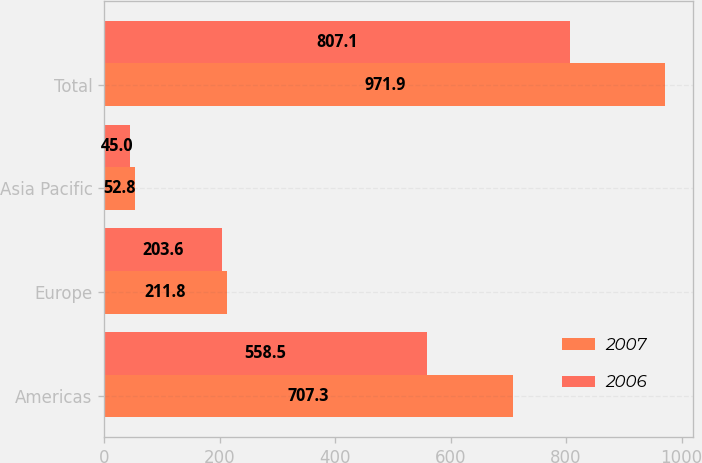Convert chart. <chart><loc_0><loc_0><loc_500><loc_500><stacked_bar_chart><ecel><fcel>Americas<fcel>Europe<fcel>Asia Pacific<fcel>Total<nl><fcel>2007<fcel>707.3<fcel>211.8<fcel>52.8<fcel>971.9<nl><fcel>2006<fcel>558.5<fcel>203.6<fcel>45<fcel>807.1<nl></chart> 